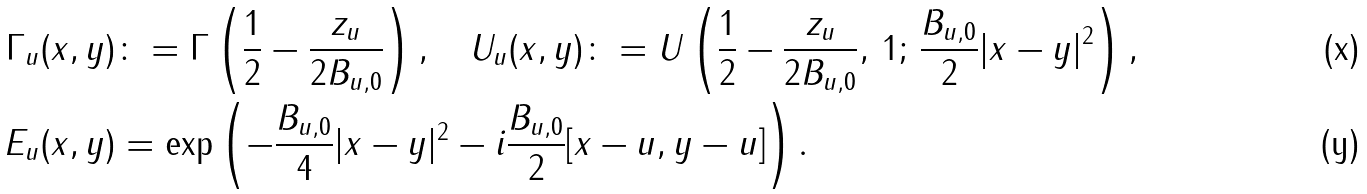Convert formula to latex. <formula><loc_0><loc_0><loc_500><loc_500>\Gamma _ { u } ( x , y ) & \colon = \Gamma \left ( \frac { 1 } { 2 } - \frac { z _ { u } } { 2 B _ { u , 0 } } \right ) , \quad U _ { u } ( x , y ) \colon = U \left ( \frac { 1 } { 2 } - \frac { z _ { u } } { 2 B _ { u , 0 } } , \, 1 ; \, \frac { B _ { u , 0 } } { 2 } | x - y | ^ { 2 } \right ) , \\ E _ { u } ( x , y ) & = \exp \left ( - \frac { B _ { u , 0 } } { 4 } | x - y | ^ { 2 } - i \frac { B _ { u , 0 } } { 2 } [ x - u , y - u ] \right ) .</formula> 